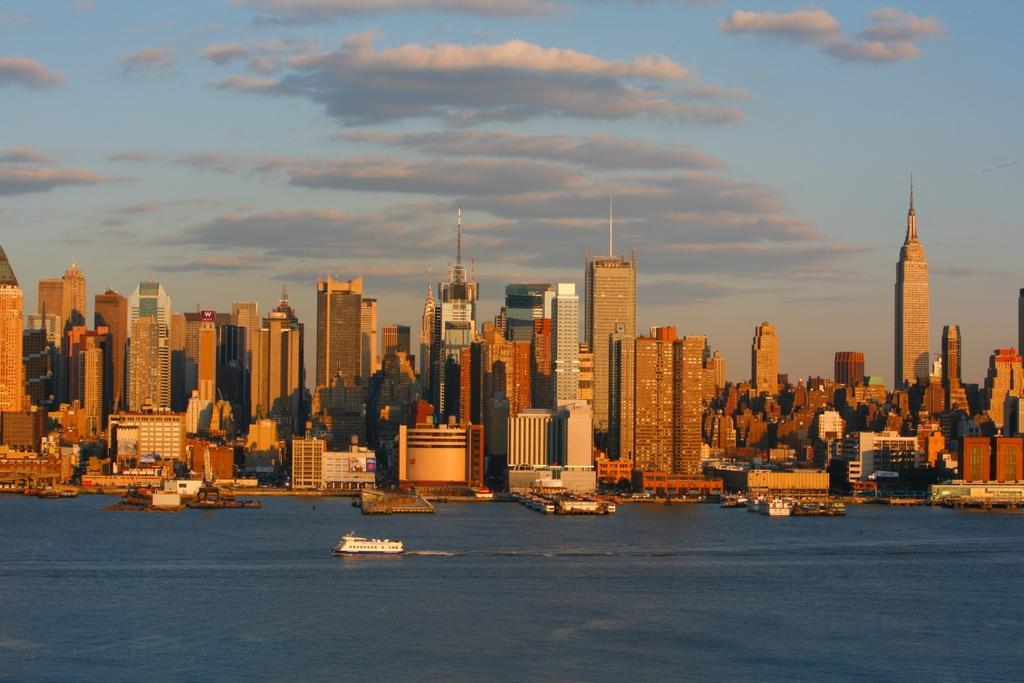What type of structures can be seen in the image? There are buildings in the image. What is present in the water in the image? There are boats in the water in the image. How would you describe the sky in the image? The sky is blue and cloudy in the image. How many clovers can be seen growing near the buildings in the image? There are no clovers visible in the image; it features buildings, boats, and a blue and cloudy sky. Are there any bikes parked near the boats in the image? There is no mention of bikes in the image; it only features buildings, boats, and a blue and cloudy sky. 